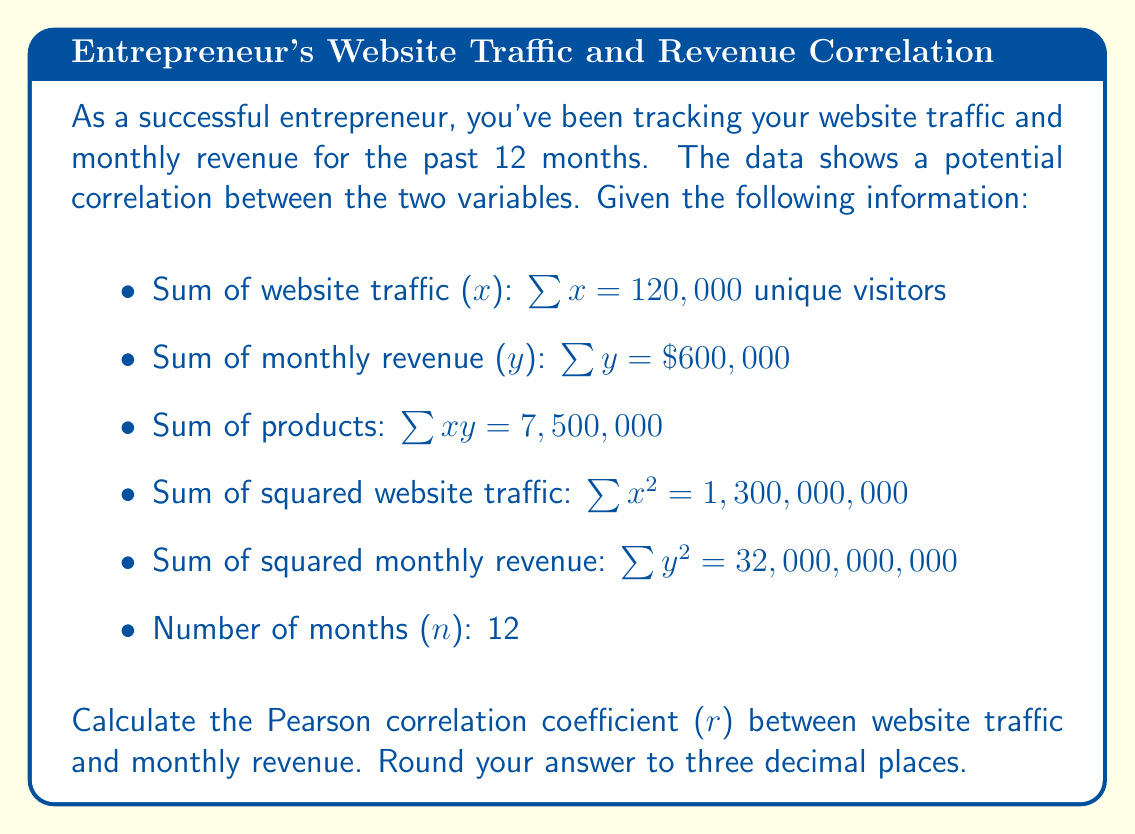Give your solution to this math problem. To calculate the Pearson correlation coefficient (r), we'll use the following formula:

$$ r = \frac{n\sum xy - \sum x \sum y}{\sqrt{[n\sum x^2 - (\sum x)^2][n\sum y^2 - (\sum y)^2]}} $$

Let's substitute the given values:

$$ r = \frac{12(7,500,000) - (120,000)(600,000)}{\sqrt{[12(1,300,000,000) - (120,000)^2][12(32,000,000,000) - (600,000)^2]}} $$

Now, let's calculate step by step:

1. Numerator:
   $12(7,500,000) - (120,000)(600,000) = 90,000,000 - 72,000,000 = 18,000,000$

2. Denominator:
   a. First part: $12(1,300,000,000) - (120,000)^2 = 15,600,000,000 - 14,400,000,000 = 1,200,000,000$
   b. Second part: $12(32,000,000,000) - (600,000)^2 = 384,000,000,000 - 360,000,000,000 = 24,000,000,000$
   c. Product: $1,200,000,000 \times 24,000,000,000 = 28,800,000,000,000,000,000$
   d. Square root: $\sqrt{28,800,000,000,000,000,000} = 169,705,627,484.77$

3. Final calculation:
   $r = \frac{18,000,000}{169,705,627,484.77} = 0.106065$

Rounding to three decimal places: $r = 0.106$
Answer: 0.106 